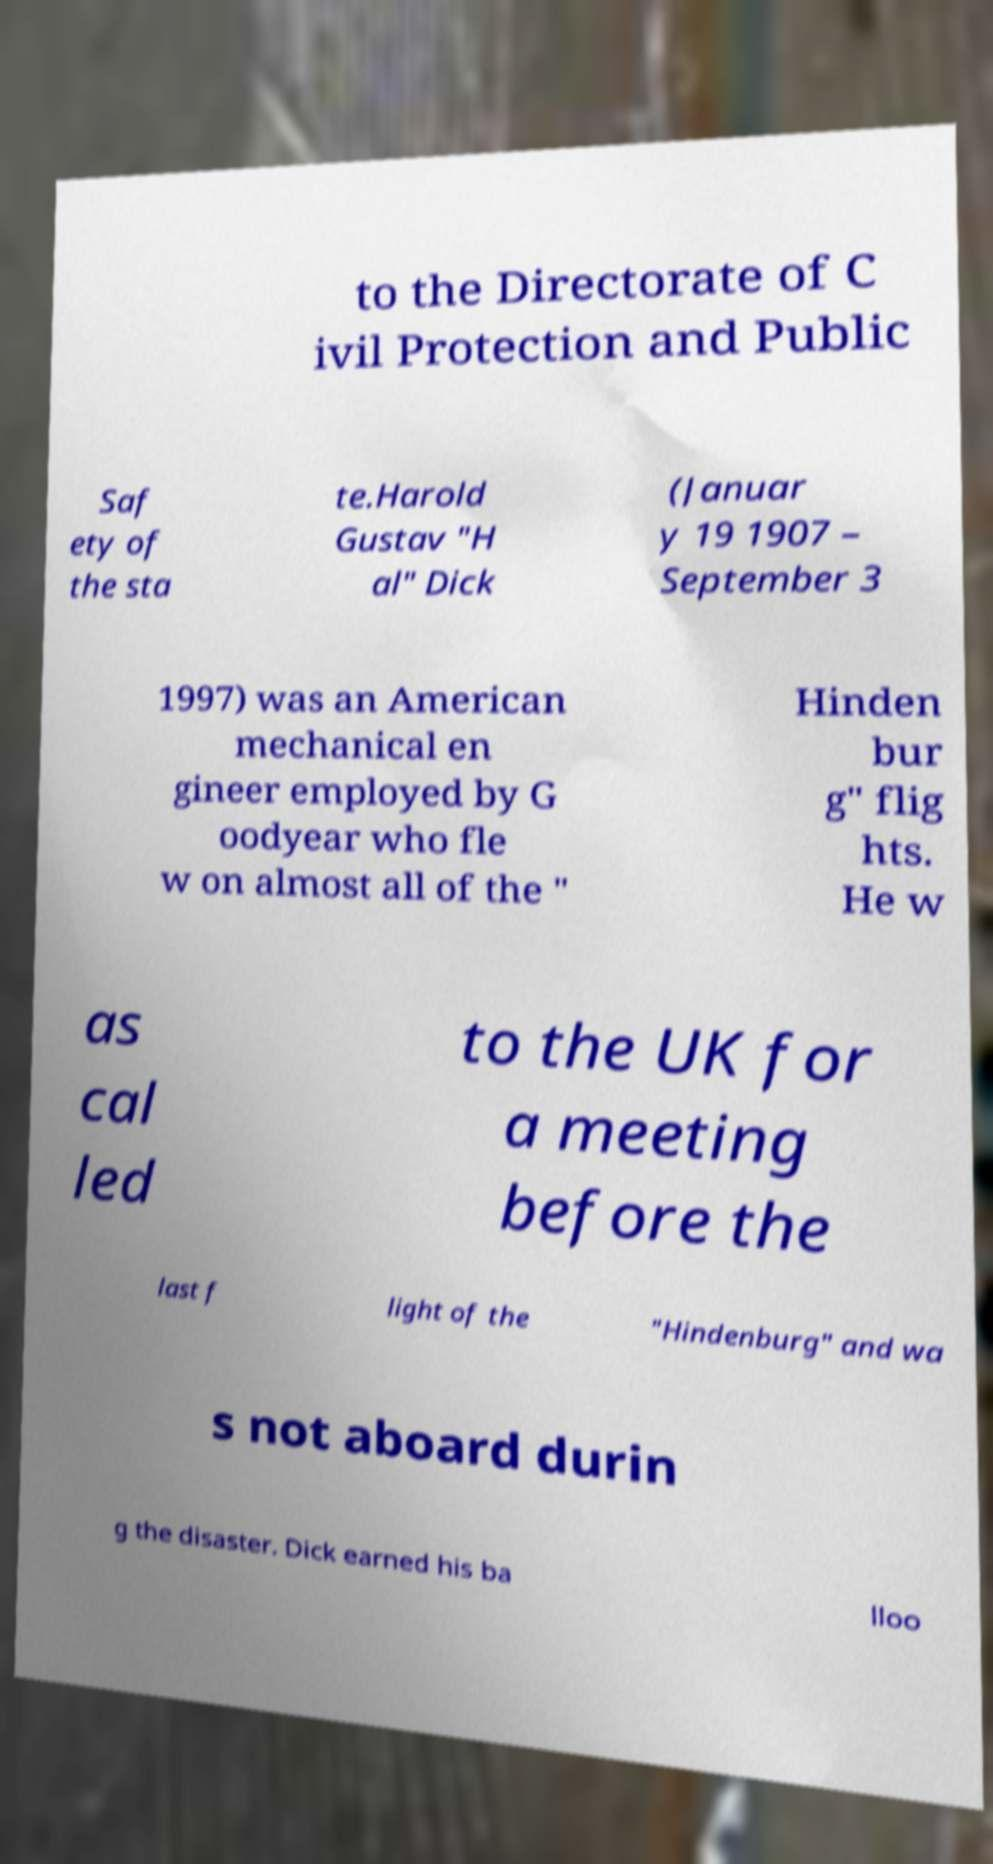Please read and relay the text visible in this image. What does it say? to the Directorate of C ivil Protection and Public Saf ety of the sta te.Harold Gustav "H al" Dick (Januar y 19 1907 – September 3 1997) was an American mechanical en gineer employed by G oodyear who fle w on almost all of the " Hinden bur g" flig hts. He w as cal led to the UK for a meeting before the last f light of the "Hindenburg" and wa s not aboard durin g the disaster. Dick earned his ba lloo 